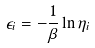Convert formula to latex. <formula><loc_0><loc_0><loc_500><loc_500>\epsilon _ { i } = - \frac { 1 } { \beta } \ln \eta _ { i }</formula> 